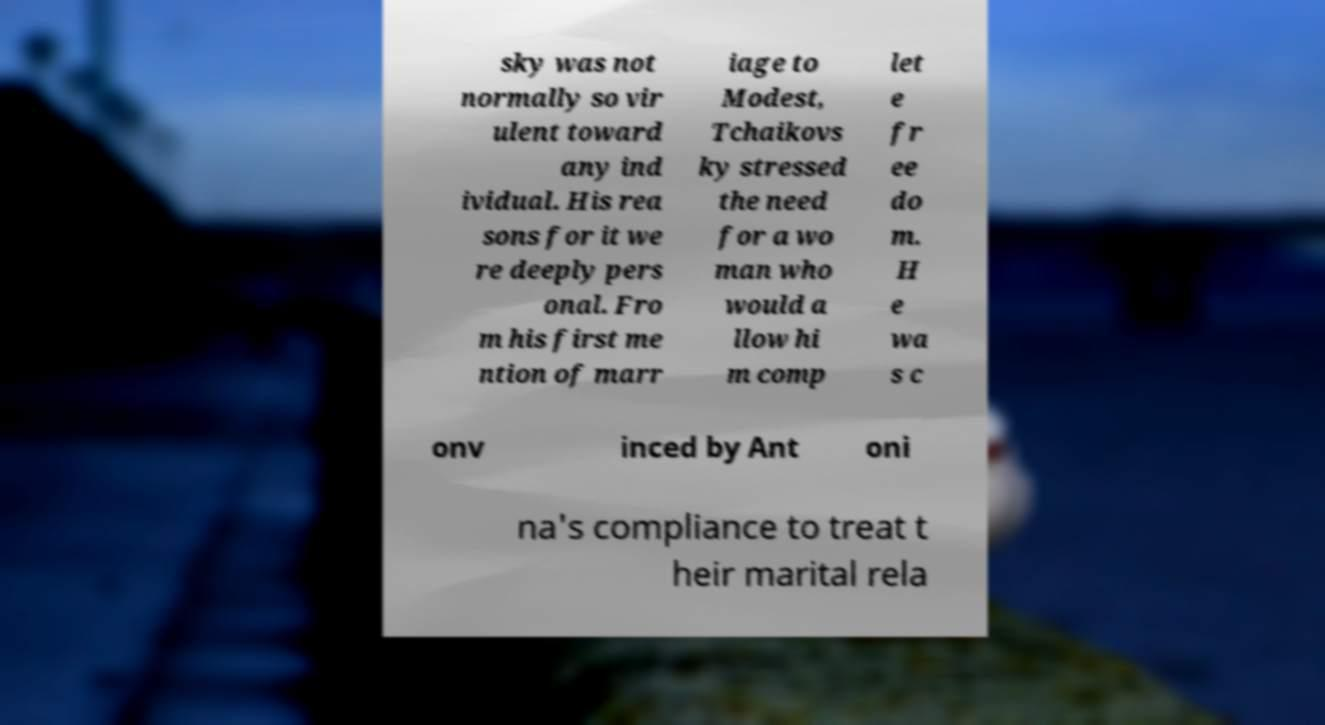Can you accurately transcribe the text from the provided image for me? sky was not normally so vir ulent toward any ind ividual. His rea sons for it we re deeply pers onal. Fro m his first me ntion of marr iage to Modest, Tchaikovs ky stressed the need for a wo man who would a llow hi m comp let e fr ee do m. H e wa s c onv inced by Ant oni na's compliance to treat t heir marital rela 